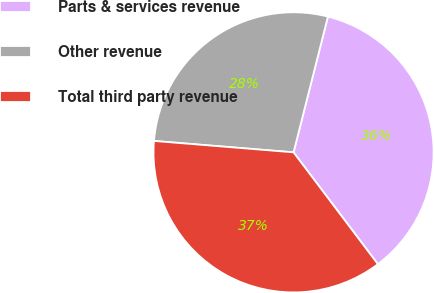Convert chart to OTSL. <chart><loc_0><loc_0><loc_500><loc_500><pie_chart><fcel>Parts & services revenue<fcel>Other revenue<fcel>Total third party revenue<nl><fcel>35.77%<fcel>27.65%<fcel>36.58%<nl></chart> 